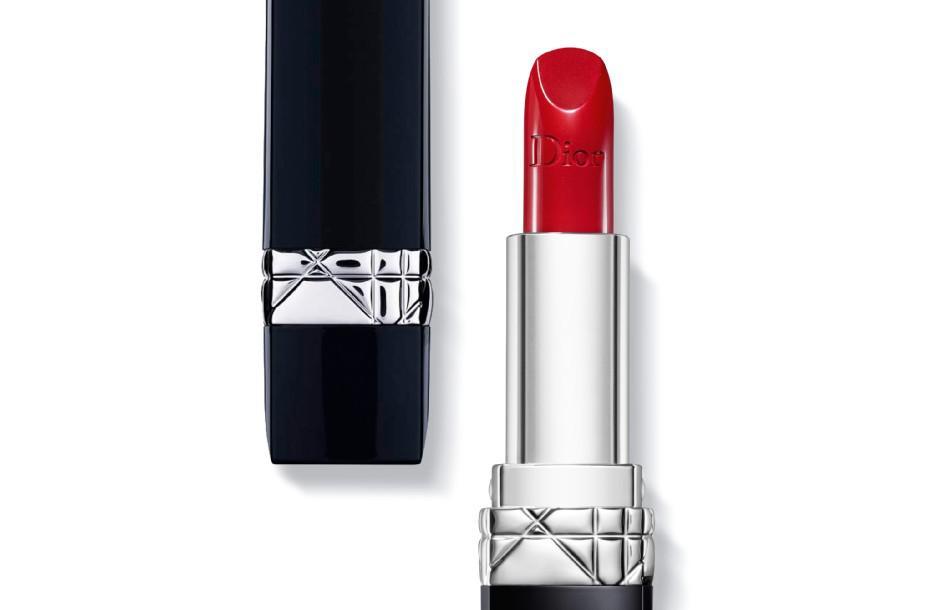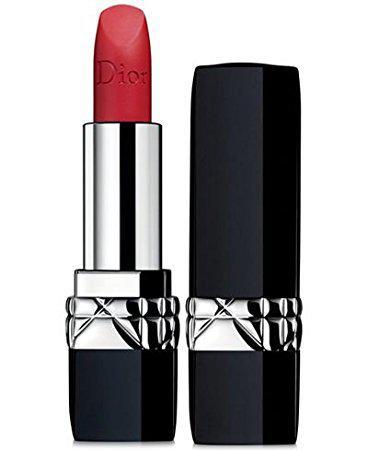The first image is the image on the left, the second image is the image on the right. For the images shown, is this caption "A red lipstick in one image is in a silver holder with black base, with a matching black cap with silver band sitting upright and level beside it." true? Answer yes or no. Yes. The first image is the image on the left, the second image is the image on the right. For the images displayed, is the sentence "A red lipstick in a silver tube is displayed level to and alongside of its upright black cap." factually correct? Answer yes or no. Yes. 